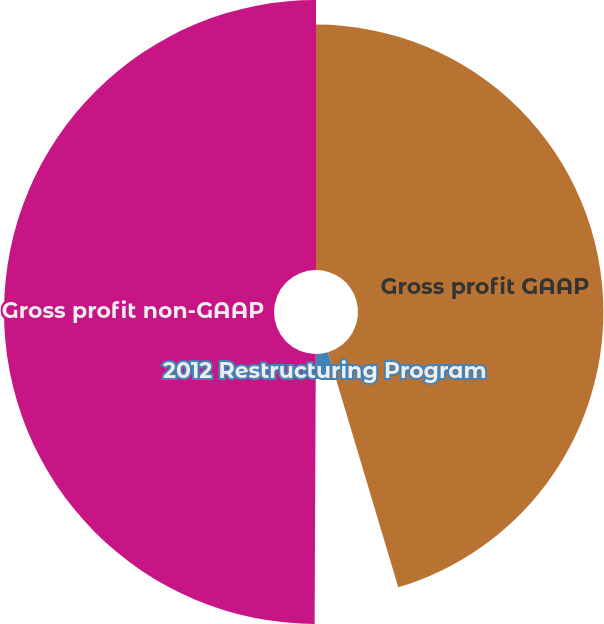Convert chart. <chart><loc_0><loc_0><loc_500><loc_500><pie_chart><fcel>Gross profit GAAP<fcel>2012 Restructuring Program<fcel>Costs related to the sale of<fcel>Gross profit non-GAAP<nl><fcel>45.38%<fcel>4.62%<fcel>0.07%<fcel>49.93%<nl></chart> 